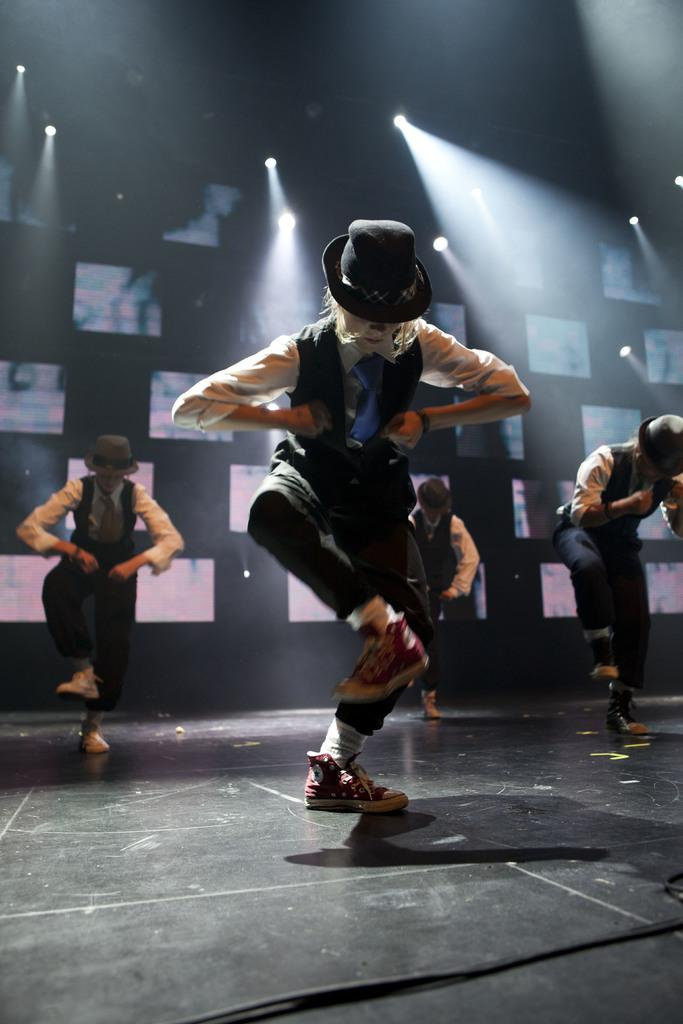How many people are in the image? There are four persons in the image. What are the persons doing in the image? The persons are dancing. What can be seen in the background of the image? There are lights and an object in the background of the image. What type of pin can be seen on the person's eyes in the image? There are no pins or references to eyes in the image; the persons are dancing, and there are lights and an object in the background. 